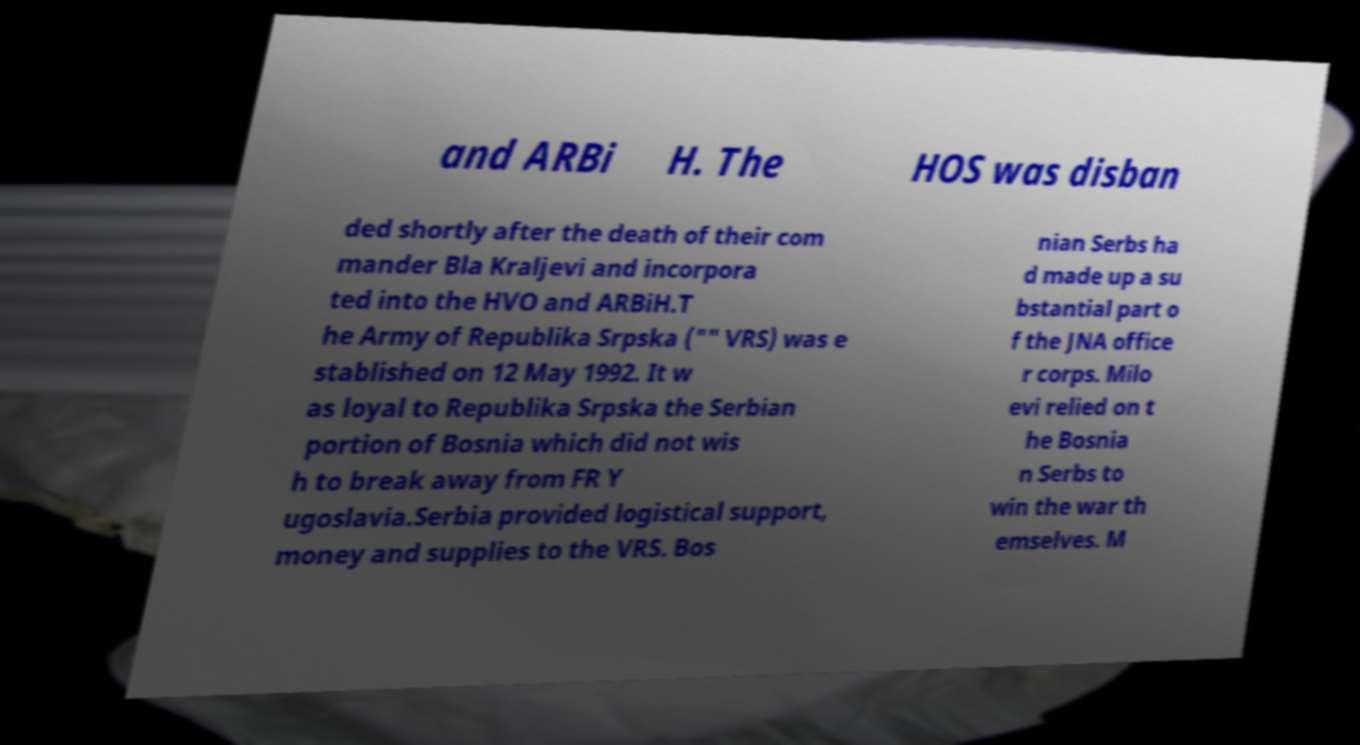Please identify and transcribe the text found in this image. and ARBi H. The HOS was disban ded shortly after the death of their com mander Bla Kraljevi and incorpora ted into the HVO and ARBiH.T he Army of Republika Srpska ("" VRS) was e stablished on 12 May 1992. It w as loyal to Republika Srpska the Serbian portion of Bosnia which did not wis h to break away from FR Y ugoslavia.Serbia provided logistical support, money and supplies to the VRS. Bos nian Serbs ha d made up a su bstantial part o f the JNA office r corps. Milo evi relied on t he Bosnia n Serbs to win the war th emselves. M 